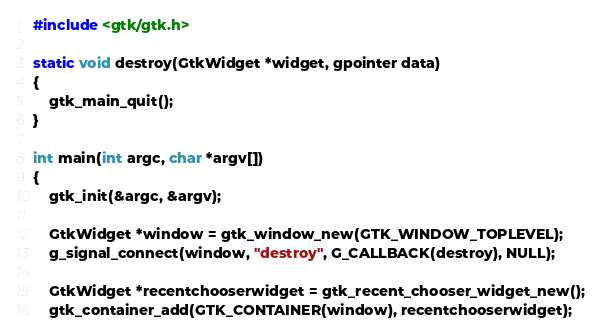<code> <loc_0><loc_0><loc_500><loc_500><_C_>#include <gtk/gtk.h>

static void destroy(GtkWidget *widget, gpointer data)
{
    gtk_main_quit();
}

int main(int argc, char *argv[])
{    
    gtk_init(&argc, &argv);
    
    GtkWidget *window = gtk_window_new(GTK_WINDOW_TOPLEVEL);
    g_signal_connect(window, "destroy", G_CALLBACK(destroy), NULL);
    
    GtkWidget *recentchooserwidget = gtk_recent_chooser_widget_new();
    gtk_container_add(GTK_CONTAINER(window), recentchooserwidget);</code> 